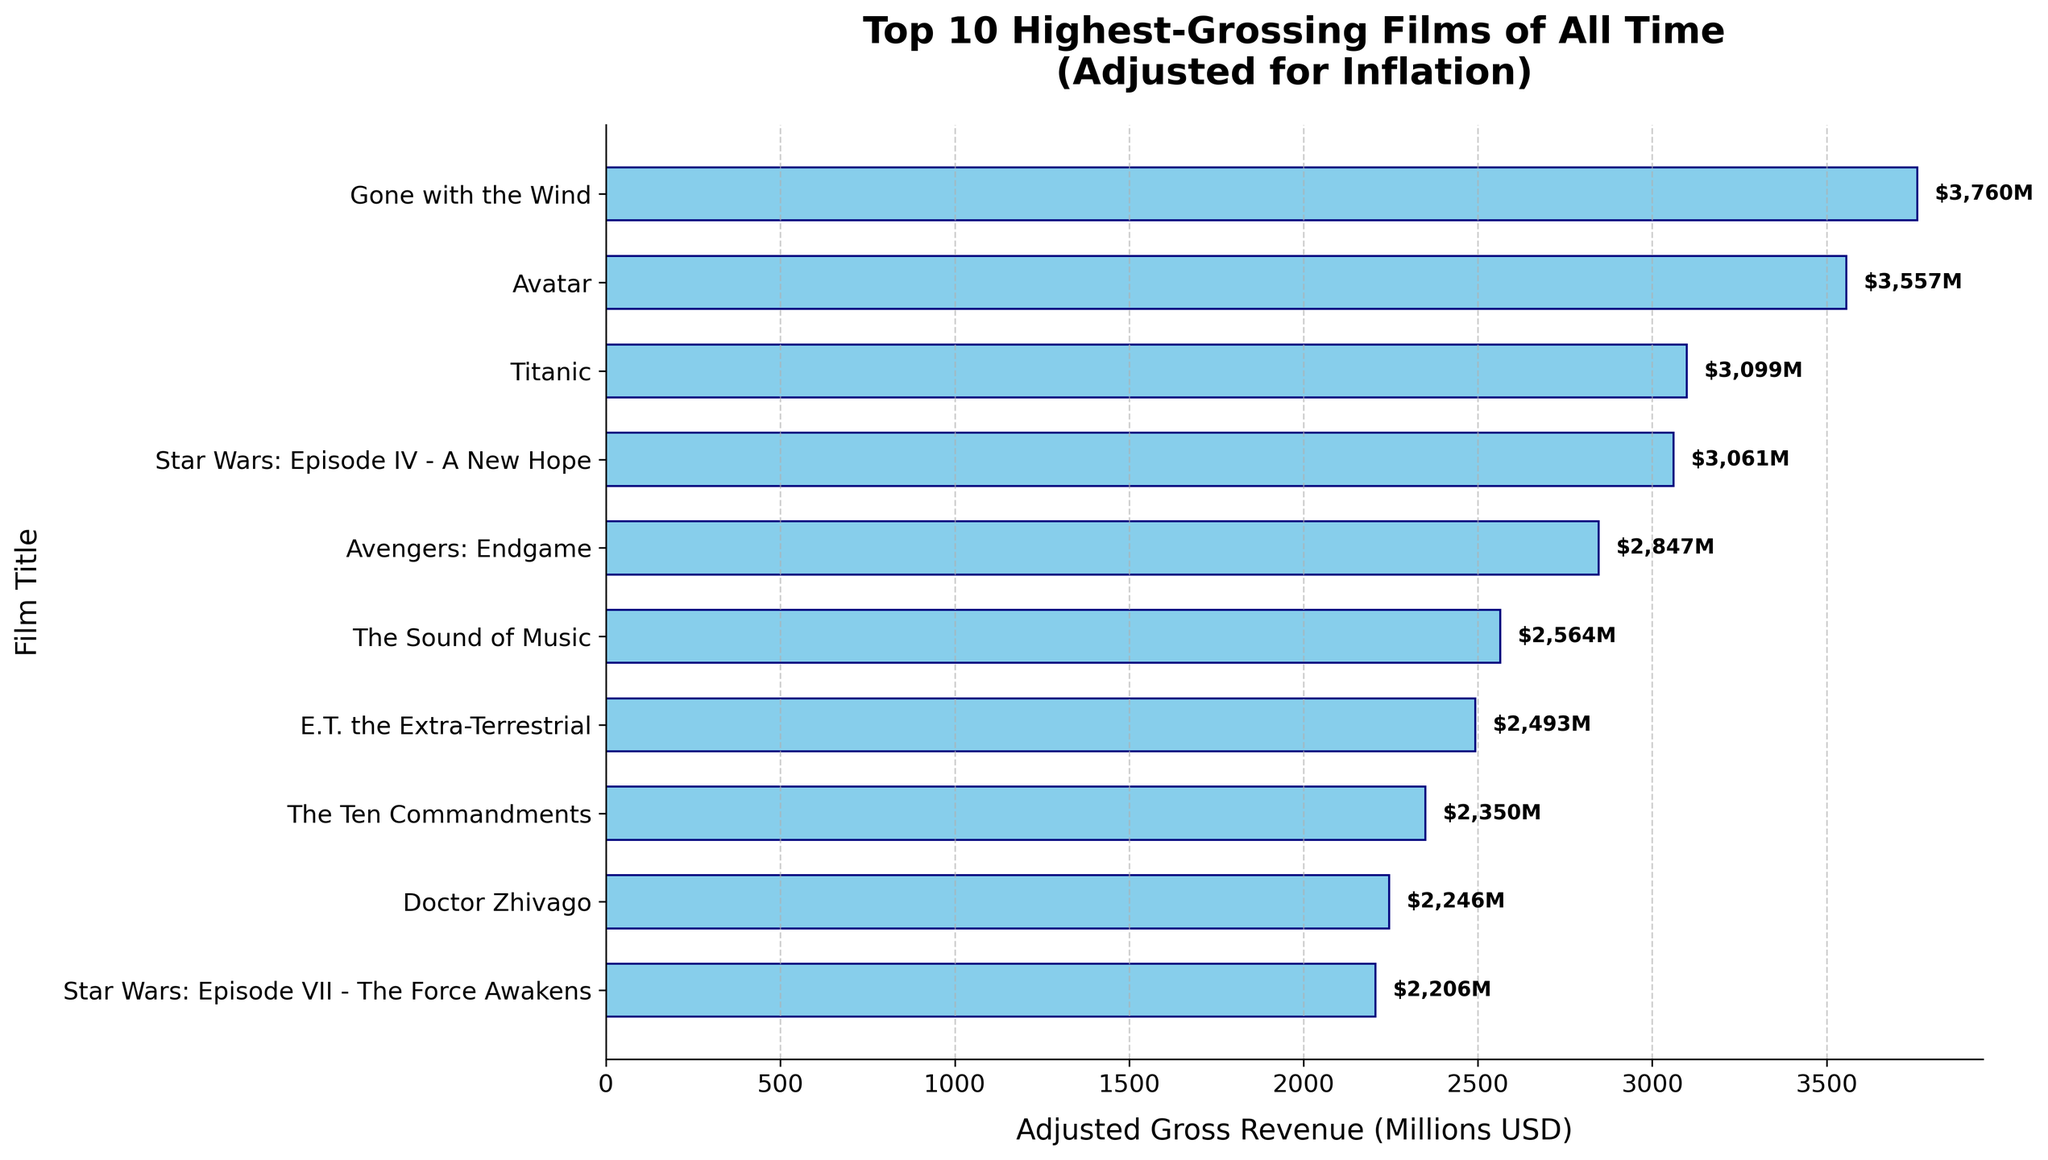Which film has the highest adjusted gross revenue? The film at the top of the bar chart has the highest adjusted gross revenue. The bar for "Gone with the Wind" is at the top and has the largest length.
Answer: Gone with the Wind Which two films have the closest adjusted gross revenues? To determine this, find two bars that are nearly equal in length. "Star Wars: Episode IV - A New Hope" and "Titantic" have very similar lengths and values.
Answer: Star Wars: Episode IV - A New Hope and Titanic What's the difference in adjusted gross revenue between the highest-grossing film and the lowest-grossing film? The adjusted gross for the highest-grossing film "Gone with the Wind" is 3760 million USD, and for the lowest-grossing film "Star Wars: Episode VII - The Force Awakens" it is 2206 million USD. The difference is 3760 - 2206 = 1554 million USD.
Answer: 1554 million USD How many films have adjusted gross revenues higher than 3000 million USD? Count the number of bars longer than 3000 million USD. "Gone with the Wind," "Avatar," "Titanic," and "Star Wars: Episode IV - A New Hope" all exceed this value.
Answer: 4 What is the combined adjusted gross revenue of "Avatar" and "Avengers: Endgame"? Look at the bars for "Avatar" (3557) and "Avengers: Endgame" (2847). Add their adjusted gross values, 3557 + 2847 = 6404 million USD.
Answer: 6404 million USD How does the adjusted gross revenue of "E.T. the Extra-Terrestrial" compare to that of "The Sound of Music"? Compare the lengths of the bars for these two films. "The Sound of Music" has a higher length (2564 million USD) compared to "E.T. the Extra-Terrestrial" (2493 million USD).
Answer: The Sound of Music has higher revenue What's the average adjusted gross revenue of the top 5 highest-grossing films? Take the sum of the revenues of the top 5 films: 3760 (Gone with the Wind), 3557 (Avatar), 3099 (Titanic), 3061 (Star Wars: Episode IV - A New Hope), and 2847 (Avengers: Endgame). The sum is 16324 million USD. Dividing by 5 gives 16324 / 5 = 3264.8 million USD.
Answer: 3264.8 million USD What is the median adjusted gross revenue among the listed films? Order the revenues and find the middle value. The revenues in order are: 2206, 2246, 2350, 2493, 2564, 2847, 3061, 3099, 3557, 3760. The median of these 10 values (average of 5th and 6th values) is (2564 + 2847) / 2 = 2705.5 million USD.
Answer: 2705.5 million USD 